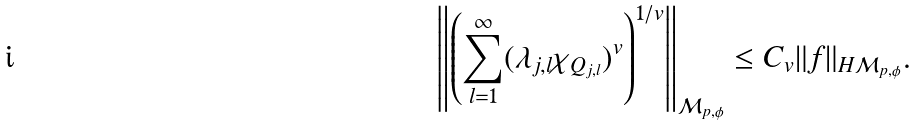<formula> <loc_0><loc_0><loc_500><loc_500>\left \| \left ( \sum _ { l = 1 } ^ { \infty } ( \lambda _ { j , l } \chi _ { Q _ { j , l } } ) ^ { v } \right ) ^ { 1 / v } \right \| _ { { \mathcal { M } } _ { p , \phi } } \leq C _ { v } \| f \| _ { H { \mathcal { M } } _ { p , \phi } } .</formula> 